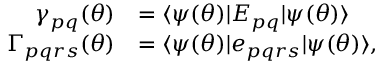Convert formula to latex. <formula><loc_0><loc_0><loc_500><loc_500>\begin{array} { r l } { \gamma _ { p q } ( { \theta } ) } & { = { \langle { \psi ( { \theta } ) } | } E _ { p q } { | { \psi ( { \theta } ) } \rangle } } \\ { \Gamma _ { p q r s } ( { \theta } ) } & { = { \langle { \psi ( { \theta } ) } | } e _ { p q r s } { | { \psi ( { \theta } ) } \rangle } , } \end{array}</formula> 